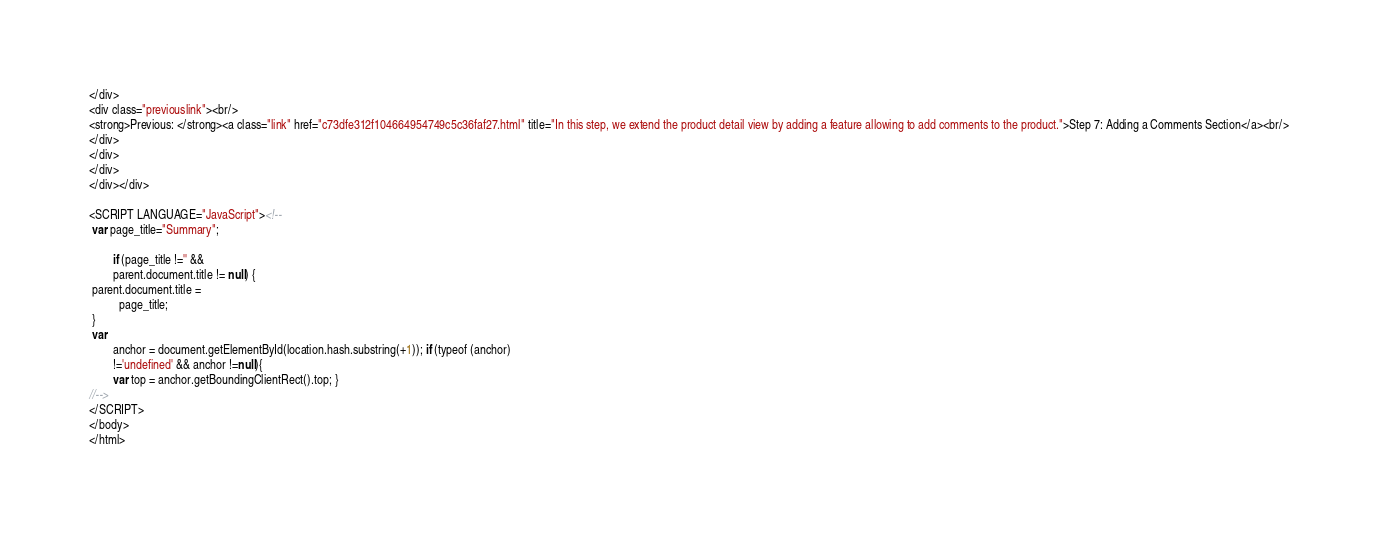Convert code to text. <code><loc_0><loc_0><loc_500><loc_500><_HTML_></div>
<div class="previouslink"><br/>
<strong>Previous: </strong><a class="link" href="c73dfe312f104664954749c5c36faf27.html" title="In this step, we extend the product detail view by adding a feature allowing to add comments to the product.">Step 7: Adding a Comments Section</a><br/>
</div>
</div>
</div>
</div></div>

<SCRIPT LANGUAGE="JavaScript"><!--
 var page_title="Summary";

        if (page_title !='' &&
        parent.document.title != null) {
 parent.document.title =
          page_title;
 } 
 var
        anchor = document.getElementById(location.hash.substring(+1)); if (typeof (anchor)
        !='undefined' && anchor !=null){
        var top = anchor.getBoundingClientRect().top; } 
//-->
</SCRIPT>
</body>
</html></code> 